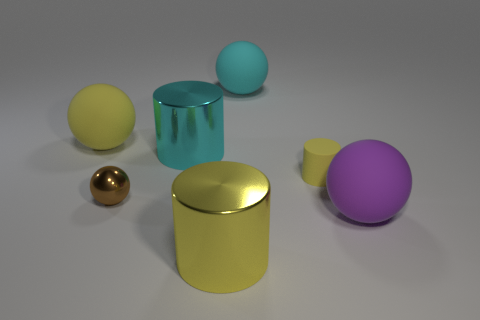Subtract all yellow cylinders. How many were subtracted if there are1yellow cylinders left? 1 Subtract all green spheres. Subtract all brown cylinders. How many spheres are left? 4 Add 1 brown objects. How many objects exist? 8 Subtract all balls. How many objects are left? 3 Add 3 large cyan objects. How many large cyan objects are left? 5 Add 6 small metal things. How many small metal things exist? 7 Subtract 0 brown cylinders. How many objects are left? 7 Subtract all small brown matte cubes. Subtract all spheres. How many objects are left? 3 